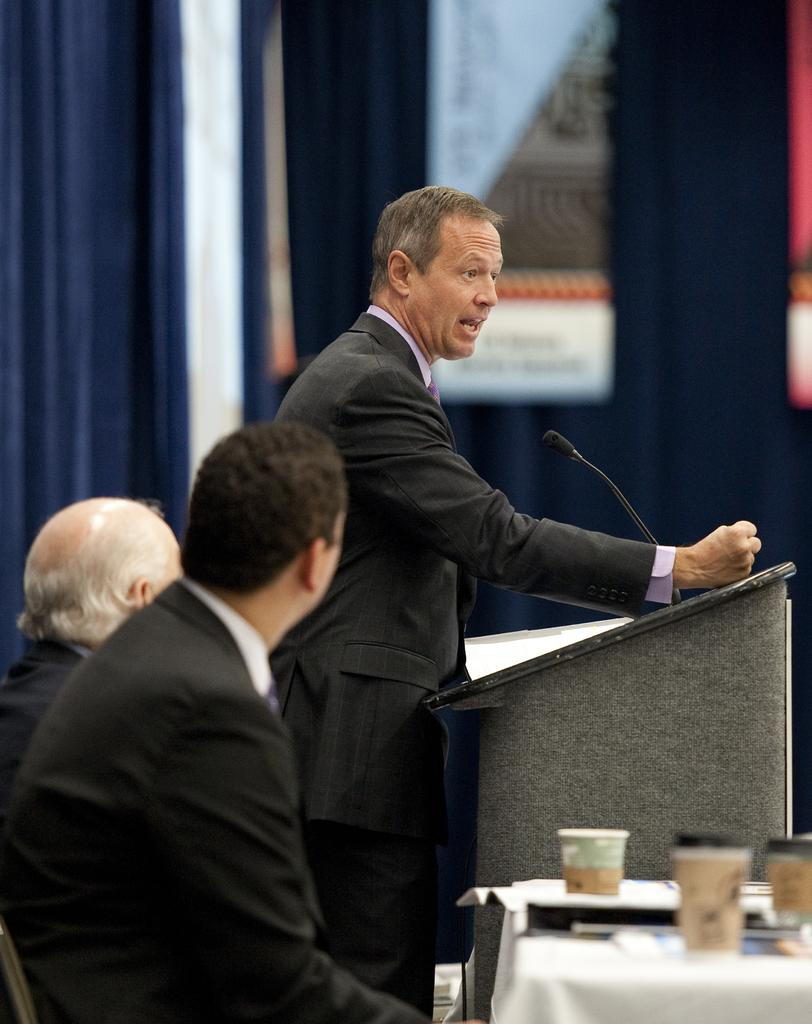What is the man in the image doing? The man is speaking in the image. Where is the man standing while speaking? The man is standing at a podium. What is the man using to amplify his voice? The man is holding a microphone. Who else is present in the image? There are two men beside the speaker. What are the two men doing? The two men are listening to the speaker. What type of screw is holding the podium together in the image? There is no screw visible in the image, and the focus is on the man speaking and the two men listening. 